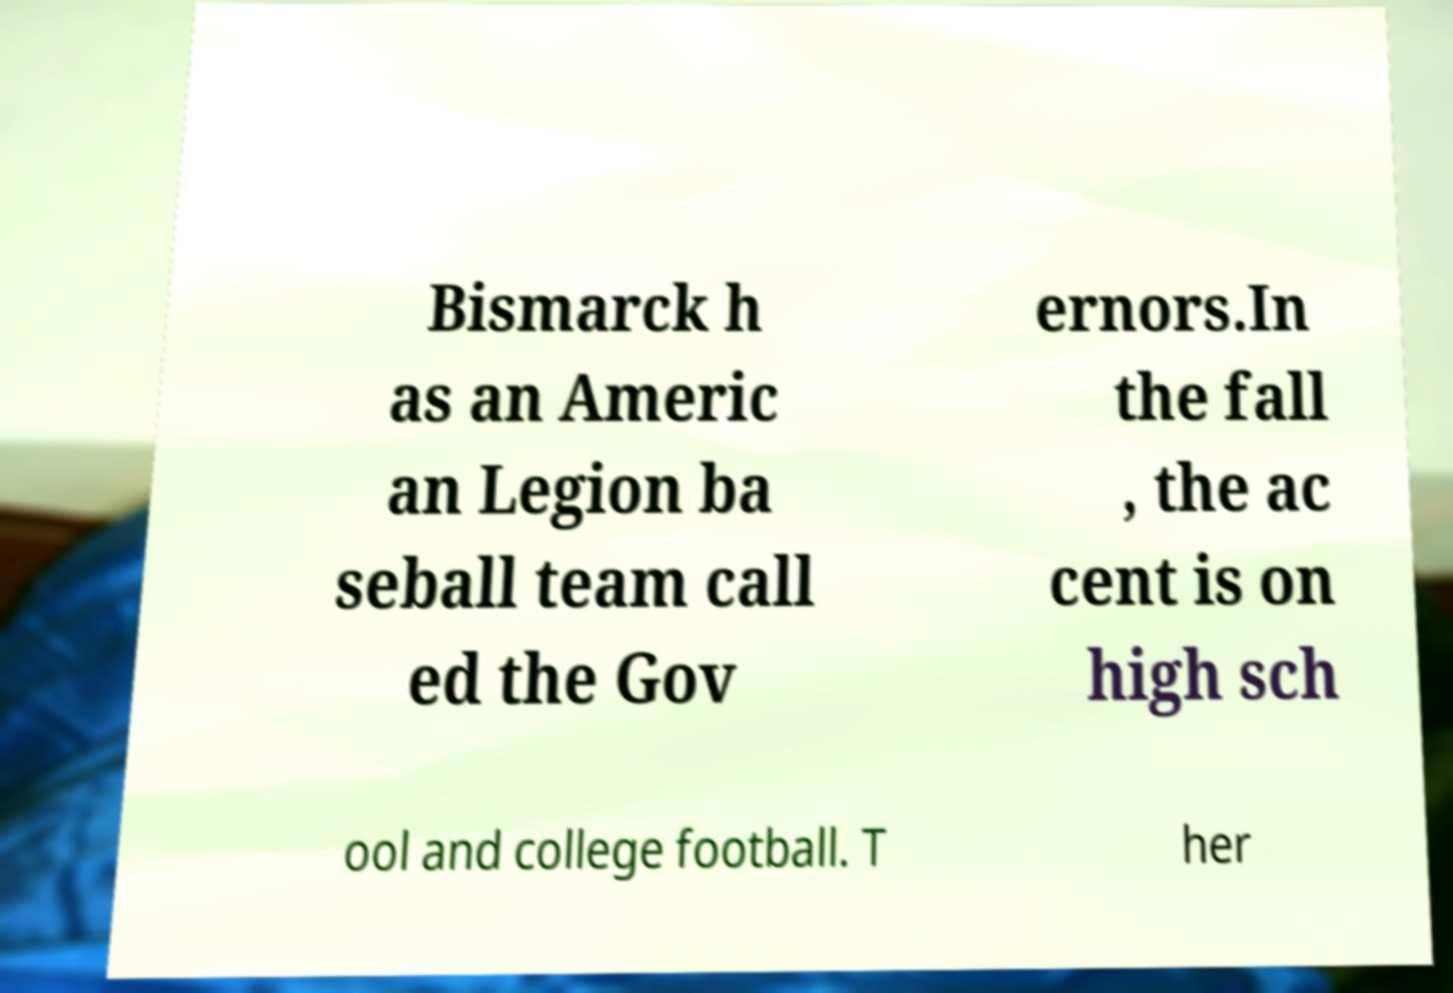Please read and relay the text visible in this image. What does it say? Bismarck h as an Americ an Legion ba seball team call ed the Gov ernors.In the fall , the ac cent is on high sch ool and college football. T her 